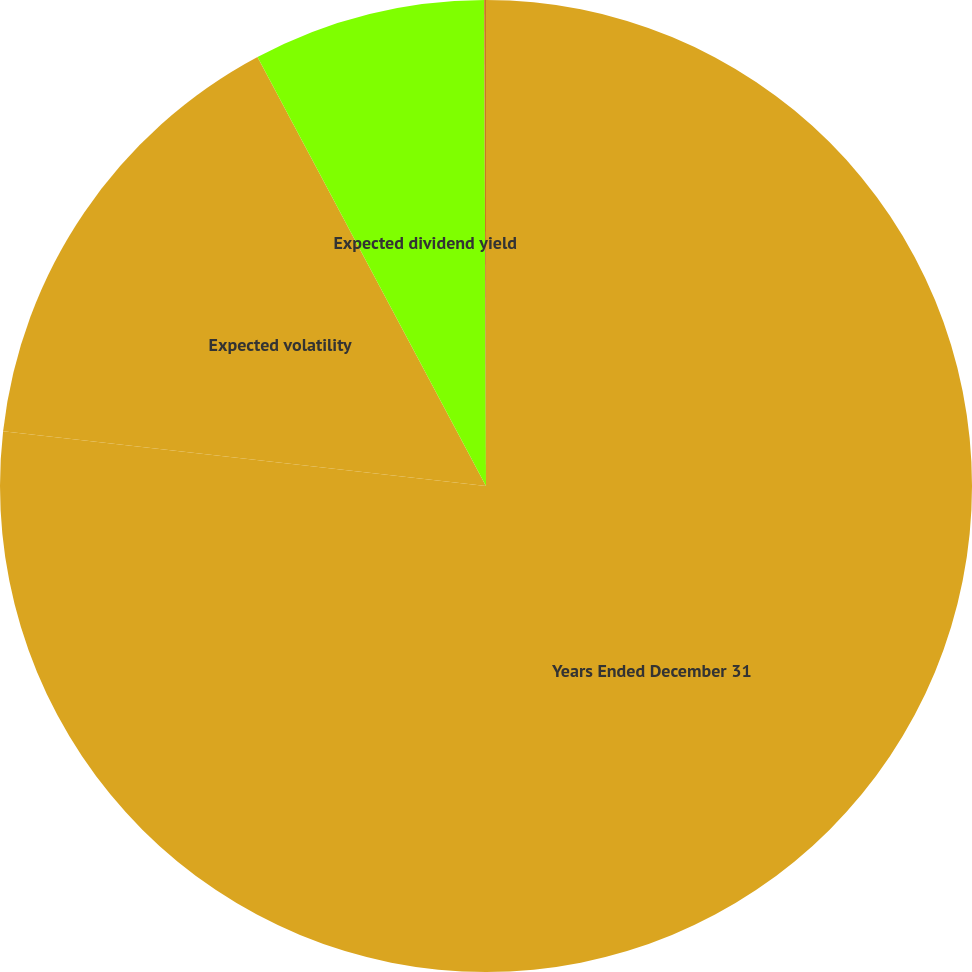<chart> <loc_0><loc_0><loc_500><loc_500><pie_chart><fcel>Years Ended December 31<fcel>Expected volatility<fcel>Expected dividend yield<fcel>Risk-free rate<nl><fcel>76.8%<fcel>15.41%<fcel>7.73%<fcel>0.06%<nl></chart> 